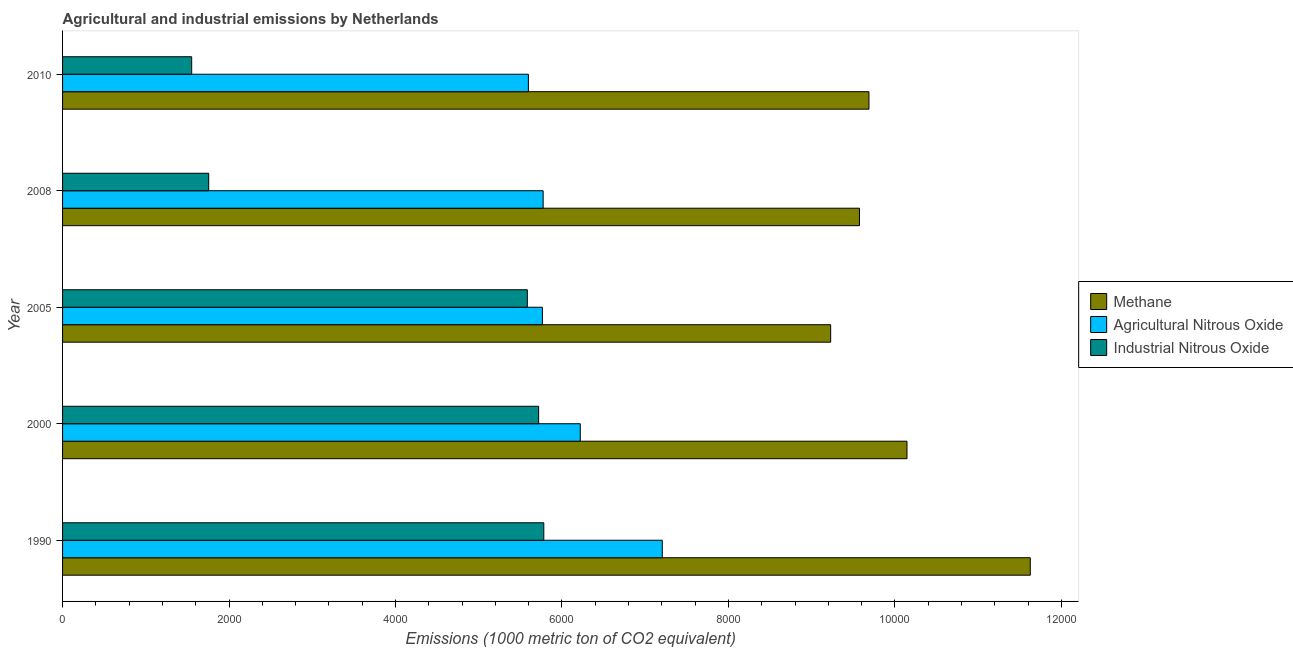Are the number of bars per tick equal to the number of legend labels?
Your response must be concise. Yes. Are the number of bars on each tick of the Y-axis equal?
Your response must be concise. Yes. How many bars are there on the 5th tick from the top?
Provide a short and direct response. 3. What is the label of the 3rd group of bars from the top?
Keep it short and to the point. 2005. What is the amount of agricultural nitrous oxide emissions in 2005?
Ensure brevity in your answer.  5764.8. Across all years, what is the maximum amount of agricultural nitrous oxide emissions?
Offer a terse response. 7205. Across all years, what is the minimum amount of methane emissions?
Your response must be concise. 9228. In which year was the amount of methane emissions maximum?
Your answer should be compact. 1990. In which year was the amount of industrial nitrous oxide emissions minimum?
Your answer should be compact. 2010. What is the total amount of agricultural nitrous oxide emissions in the graph?
Ensure brevity in your answer.  3.06e+04. What is the difference between the amount of industrial nitrous oxide emissions in 2005 and that in 2008?
Your answer should be compact. 3827.9. What is the difference between the amount of industrial nitrous oxide emissions in 2000 and the amount of agricultural nitrous oxide emissions in 2005?
Keep it short and to the point. -45.3. What is the average amount of methane emissions per year?
Keep it short and to the point. 1.01e+04. In the year 2000, what is the difference between the amount of methane emissions and amount of industrial nitrous oxide emissions?
Ensure brevity in your answer.  4425.3. What is the ratio of the amount of industrial nitrous oxide emissions in 2008 to that in 2010?
Ensure brevity in your answer.  1.13. Is the difference between the amount of industrial nitrous oxide emissions in 1990 and 2010 greater than the difference between the amount of methane emissions in 1990 and 2010?
Offer a very short reply. Yes. What is the difference between the highest and the second highest amount of agricultural nitrous oxide emissions?
Give a very brief answer. 985.5. What is the difference between the highest and the lowest amount of agricultural nitrous oxide emissions?
Give a very brief answer. 1608.7. Is the sum of the amount of methane emissions in 2005 and 2008 greater than the maximum amount of agricultural nitrous oxide emissions across all years?
Ensure brevity in your answer.  Yes. What does the 2nd bar from the top in 1990 represents?
Make the answer very short. Agricultural Nitrous Oxide. What does the 1st bar from the bottom in 1990 represents?
Provide a succinct answer. Methane. How many bars are there?
Keep it short and to the point. 15. Are all the bars in the graph horizontal?
Offer a very short reply. Yes. Are the values on the major ticks of X-axis written in scientific E-notation?
Your answer should be very brief. No. Does the graph contain any zero values?
Your answer should be very brief. No. Does the graph contain grids?
Make the answer very short. No. Where does the legend appear in the graph?
Provide a succinct answer. Center right. How many legend labels are there?
Your answer should be compact. 3. What is the title of the graph?
Provide a succinct answer. Agricultural and industrial emissions by Netherlands. Does "Grants" appear as one of the legend labels in the graph?
Your response must be concise. No. What is the label or title of the X-axis?
Ensure brevity in your answer.  Emissions (1000 metric ton of CO2 equivalent). What is the label or title of the Y-axis?
Your response must be concise. Year. What is the Emissions (1000 metric ton of CO2 equivalent) in Methane in 1990?
Offer a very short reply. 1.16e+04. What is the Emissions (1000 metric ton of CO2 equivalent) of Agricultural Nitrous Oxide in 1990?
Offer a terse response. 7205. What is the Emissions (1000 metric ton of CO2 equivalent) in Industrial Nitrous Oxide in 1990?
Make the answer very short. 5781.5. What is the Emissions (1000 metric ton of CO2 equivalent) in Methane in 2000?
Offer a very short reply. 1.01e+04. What is the Emissions (1000 metric ton of CO2 equivalent) of Agricultural Nitrous Oxide in 2000?
Your response must be concise. 6219.5. What is the Emissions (1000 metric ton of CO2 equivalent) of Industrial Nitrous Oxide in 2000?
Ensure brevity in your answer.  5719.5. What is the Emissions (1000 metric ton of CO2 equivalent) of Methane in 2005?
Give a very brief answer. 9228. What is the Emissions (1000 metric ton of CO2 equivalent) of Agricultural Nitrous Oxide in 2005?
Offer a terse response. 5764.8. What is the Emissions (1000 metric ton of CO2 equivalent) in Industrial Nitrous Oxide in 2005?
Your response must be concise. 5583.6. What is the Emissions (1000 metric ton of CO2 equivalent) in Methane in 2008?
Ensure brevity in your answer.  9574.5. What is the Emissions (1000 metric ton of CO2 equivalent) of Agricultural Nitrous Oxide in 2008?
Your answer should be compact. 5773.6. What is the Emissions (1000 metric ton of CO2 equivalent) in Industrial Nitrous Oxide in 2008?
Give a very brief answer. 1755.7. What is the Emissions (1000 metric ton of CO2 equivalent) in Methane in 2010?
Provide a succinct answer. 9687.8. What is the Emissions (1000 metric ton of CO2 equivalent) in Agricultural Nitrous Oxide in 2010?
Your answer should be very brief. 5596.3. What is the Emissions (1000 metric ton of CO2 equivalent) of Industrial Nitrous Oxide in 2010?
Offer a very short reply. 1551.3. Across all years, what is the maximum Emissions (1000 metric ton of CO2 equivalent) of Methane?
Ensure brevity in your answer.  1.16e+04. Across all years, what is the maximum Emissions (1000 metric ton of CO2 equivalent) in Agricultural Nitrous Oxide?
Provide a succinct answer. 7205. Across all years, what is the maximum Emissions (1000 metric ton of CO2 equivalent) of Industrial Nitrous Oxide?
Your answer should be very brief. 5781.5. Across all years, what is the minimum Emissions (1000 metric ton of CO2 equivalent) in Methane?
Your response must be concise. 9228. Across all years, what is the minimum Emissions (1000 metric ton of CO2 equivalent) of Agricultural Nitrous Oxide?
Offer a terse response. 5596.3. Across all years, what is the minimum Emissions (1000 metric ton of CO2 equivalent) in Industrial Nitrous Oxide?
Your answer should be compact. 1551.3. What is the total Emissions (1000 metric ton of CO2 equivalent) in Methane in the graph?
Offer a terse response. 5.03e+04. What is the total Emissions (1000 metric ton of CO2 equivalent) in Agricultural Nitrous Oxide in the graph?
Provide a succinct answer. 3.06e+04. What is the total Emissions (1000 metric ton of CO2 equivalent) in Industrial Nitrous Oxide in the graph?
Your answer should be very brief. 2.04e+04. What is the difference between the Emissions (1000 metric ton of CO2 equivalent) of Methane in 1990 and that in 2000?
Offer a very short reply. 1481.2. What is the difference between the Emissions (1000 metric ton of CO2 equivalent) of Agricultural Nitrous Oxide in 1990 and that in 2000?
Make the answer very short. 985.5. What is the difference between the Emissions (1000 metric ton of CO2 equivalent) of Methane in 1990 and that in 2005?
Your answer should be compact. 2398. What is the difference between the Emissions (1000 metric ton of CO2 equivalent) in Agricultural Nitrous Oxide in 1990 and that in 2005?
Offer a terse response. 1440.2. What is the difference between the Emissions (1000 metric ton of CO2 equivalent) of Industrial Nitrous Oxide in 1990 and that in 2005?
Offer a terse response. 197.9. What is the difference between the Emissions (1000 metric ton of CO2 equivalent) of Methane in 1990 and that in 2008?
Provide a succinct answer. 2051.5. What is the difference between the Emissions (1000 metric ton of CO2 equivalent) of Agricultural Nitrous Oxide in 1990 and that in 2008?
Offer a terse response. 1431.4. What is the difference between the Emissions (1000 metric ton of CO2 equivalent) of Industrial Nitrous Oxide in 1990 and that in 2008?
Give a very brief answer. 4025.8. What is the difference between the Emissions (1000 metric ton of CO2 equivalent) of Methane in 1990 and that in 2010?
Keep it short and to the point. 1938.2. What is the difference between the Emissions (1000 metric ton of CO2 equivalent) in Agricultural Nitrous Oxide in 1990 and that in 2010?
Your answer should be compact. 1608.7. What is the difference between the Emissions (1000 metric ton of CO2 equivalent) in Industrial Nitrous Oxide in 1990 and that in 2010?
Make the answer very short. 4230.2. What is the difference between the Emissions (1000 metric ton of CO2 equivalent) in Methane in 2000 and that in 2005?
Ensure brevity in your answer.  916.8. What is the difference between the Emissions (1000 metric ton of CO2 equivalent) of Agricultural Nitrous Oxide in 2000 and that in 2005?
Your answer should be very brief. 454.7. What is the difference between the Emissions (1000 metric ton of CO2 equivalent) in Industrial Nitrous Oxide in 2000 and that in 2005?
Give a very brief answer. 135.9. What is the difference between the Emissions (1000 metric ton of CO2 equivalent) of Methane in 2000 and that in 2008?
Offer a very short reply. 570.3. What is the difference between the Emissions (1000 metric ton of CO2 equivalent) of Agricultural Nitrous Oxide in 2000 and that in 2008?
Give a very brief answer. 445.9. What is the difference between the Emissions (1000 metric ton of CO2 equivalent) of Industrial Nitrous Oxide in 2000 and that in 2008?
Make the answer very short. 3963.8. What is the difference between the Emissions (1000 metric ton of CO2 equivalent) of Methane in 2000 and that in 2010?
Give a very brief answer. 457. What is the difference between the Emissions (1000 metric ton of CO2 equivalent) in Agricultural Nitrous Oxide in 2000 and that in 2010?
Keep it short and to the point. 623.2. What is the difference between the Emissions (1000 metric ton of CO2 equivalent) of Industrial Nitrous Oxide in 2000 and that in 2010?
Keep it short and to the point. 4168.2. What is the difference between the Emissions (1000 metric ton of CO2 equivalent) of Methane in 2005 and that in 2008?
Offer a very short reply. -346.5. What is the difference between the Emissions (1000 metric ton of CO2 equivalent) of Industrial Nitrous Oxide in 2005 and that in 2008?
Offer a terse response. 3827.9. What is the difference between the Emissions (1000 metric ton of CO2 equivalent) of Methane in 2005 and that in 2010?
Offer a terse response. -459.8. What is the difference between the Emissions (1000 metric ton of CO2 equivalent) in Agricultural Nitrous Oxide in 2005 and that in 2010?
Your answer should be compact. 168.5. What is the difference between the Emissions (1000 metric ton of CO2 equivalent) of Industrial Nitrous Oxide in 2005 and that in 2010?
Your answer should be very brief. 4032.3. What is the difference between the Emissions (1000 metric ton of CO2 equivalent) of Methane in 2008 and that in 2010?
Offer a very short reply. -113.3. What is the difference between the Emissions (1000 metric ton of CO2 equivalent) of Agricultural Nitrous Oxide in 2008 and that in 2010?
Provide a short and direct response. 177.3. What is the difference between the Emissions (1000 metric ton of CO2 equivalent) of Industrial Nitrous Oxide in 2008 and that in 2010?
Offer a very short reply. 204.4. What is the difference between the Emissions (1000 metric ton of CO2 equivalent) in Methane in 1990 and the Emissions (1000 metric ton of CO2 equivalent) in Agricultural Nitrous Oxide in 2000?
Your response must be concise. 5406.5. What is the difference between the Emissions (1000 metric ton of CO2 equivalent) in Methane in 1990 and the Emissions (1000 metric ton of CO2 equivalent) in Industrial Nitrous Oxide in 2000?
Offer a very short reply. 5906.5. What is the difference between the Emissions (1000 metric ton of CO2 equivalent) in Agricultural Nitrous Oxide in 1990 and the Emissions (1000 metric ton of CO2 equivalent) in Industrial Nitrous Oxide in 2000?
Ensure brevity in your answer.  1485.5. What is the difference between the Emissions (1000 metric ton of CO2 equivalent) of Methane in 1990 and the Emissions (1000 metric ton of CO2 equivalent) of Agricultural Nitrous Oxide in 2005?
Your answer should be compact. 5861.2. What is the difference between the Emissions (1000 metric ton of CO2 equivalent) of Methane in 1990 and the Emissions (1000 metric ton of CO2 equivalent) of Industrial Nitrous Oxide in 2005?
Your answer should be compact. 6042.4. What is the difference between the Emissions (1000 metric ton of CO2 equivalent) in Agricultural Nitrous Oxide in 1990 and the Emissions (1000 metric ton of CO2 equivalent) in Industrial Nitrous Oxide in 2005?
Give a very brief answer. 1621.4. What is the difference between the Emissions (1000 metric ton of CO2 equivalent) of Methane in 1990 and the Emissions (1000 metric ton of CO2 equivalent) of Agricultural Nitrous Oxide in 2008?
Offer a terse response. 5852.4. What is the difference between the Emissions (1000 metric ton of CO2 equivalent) in Methane in 1990 and the Emissions (1000 metric ton of CO2 equivalent) in Industrial Nitrous Oxide in 2008?
Your response must be concise. 9870.3. What is the difference between the Emissions (1000 metric ton of CO2 equivalent) in Agricultural Nitrous Oxide in 1990 and the Emissions (1000 metric ton of CO2 equivalent) in Industrial Nitrous Oxide in 2008?
Your answer should be compact. 5449.3. What is the difference between the Emissions (1000 metric ton of CO2 equivalent) in Methane in 1990 and the Emissions (1000 metric ton of CO2 equivalent) in Agricultural Nitrous Oxide in 2010?
Your answer should be compact. 6029.7. What is the difference between the Emissions (1000 metric ton of CO2 equivalent) of Methane in 1990 and the Emissions (1000 metric ton of CO2 equivalent) of Industrial Nitrous Oxide in 2010?
Provide a succinct answer. 1.01e+04. What is the difference between the Emissions (1000 metric ton of CO2 equivalent) in Agricultural Nitrous Oxide in 1990 and the Emissions (1000 metric ton of CO2 equivalent) in Industrial Nitrous Oxide in 2010?
Make the answer very short. 5653.7. What is the difference between the Emissions (1000 metric ton of CO2 equivalent) in Methane in 2000 and the Emissions (1000 metric ton of CO2 equivalent) in Agricultural Nitrous Oxide in 2005?
Ensure brevity in your answer.  4380. What is the difference between the Emissions (1000 metric ton of CO2 equivalent) of Methane in 2000 and the Emissions (1000 metric ton of CO2 equivalent) of Industrial Nitrous Oxide in 2005?
Make the answer very short. 4561.2. What is the difference between the Emissions (1000 metric ton of CO2 equivalent) of Agricultural Nitrous Oxide in 2000 and the Emissions (1000 metric ton of CO2 equivalent) of Industrial Nitrous Oxide in 2005?
Offer a terse response. 635.9. What is the difference between the Emissions (1000 metric ton of CO2 equivalent) in Methane in 2000 and the Emissions (1000 metric ton of CO2 equivalent) in Agricultural Nitrous Oxide in 2008?
Offer a very short reply. 4371.2. What is the difference between the Emissions (1000 metric ton of CO2 equivalent) in Methane in 2000 and the Emissions (1000 metric ton of CO2 equivalent) in Industrial Nitrous Oxide in 2008?
Ensure brevity in your answer.  8389.1. What is the difference between the Emissions (1000 metric ton of CO2 equivalent) of Agricultural Nitrous Oxide in 2000 and the Emissions (1000 metric ton of CO2 equivalent) of Industrial Nitrous Oxide in 2008?
Offer a terse response. 4463.8. What is the difference between the Emissions (1000 metric ton of CO2 equivalent) of Methane in 2000 and the Emissions (1000 metric ton of CO2 equivalent) of Agricultural Nitrous Oxide in 2010?
Keep it short and to the point. 4548.5. What is the difference between the Emissions (1000 metric ton of CO2 equivalent) in Methane in 2000 and the Emissions (1000 metric ton of CO2 equivalent) in Industrial Nitrous Oxide in 2010?
Your answer should be very brief. 8593.5. What is the difference between the Emissions (1000 metric ton of CO2 equivalent) in Agricultural Nitrous Oxide in 2000 and the Emissions (1000 metric ton of CO2 equivalent) in Industrial Nitrous Oxide in 2010?
Give a very brief answer. 4668.2. What is the difference between the Emissions (1000 metric ton of CO2 equivalent) of Methane in 2005 and the Emissions (1000 metric ton of CO2 equivalent) of Agricultural Nitrous Oxide in 2008?
Make the answer very short. 3454.4. What is the difference between the Emissions (1000 metric ton of CO2 equivalent) of Methane in 2005 and the Emissions (1000 metric ton of CO2 equivalent) of Industrial Nitrous Oxide in 2008?
Ensure brevity in your answer.  7472.3. What is the difference between the Emissions (1000 metric ton of CO2 equivalent) of Agricultural Nitrous Oxide in 2005 and the Emissions (1000 metric ton of CO2 equivalent) of Industrial Nitrous Oxide in 2008?
Your response must be concise. 4009.1. What is the difference between the Emissions (1000 metric ton of CO2 equivalent) in Methane in 2005 and the Emissions (1000 metric ton of CO2 equivalent) in Agricultural Nitrous Oxide in 2010?
Make the answer very short. 3631.7. What is the difference between the Emissions (1000 metric ton of CO2 equivalent) of Methane in 2005 and the Emissions (1000 metric ton of CO2 equivalent) of Industrial Nitrous Oxide in 2010?
Your answer should be very brief. 7676.7. What is the difference between the Emissions (1000 metric ton of CO2 equivalent) of Agricultural Nitrous Oxide in 2005 and the Emissions (1000 metric ton of CO2 equivalent) of Industrial Nitrous Oxide in 2010?
Make the answer very short. 4213.5. What is the difference between the Emissions (1000 metric ton of CO2 equivalent) of Methane in 2008 and the Emissions (1000 metric ton of CO2 equivalent) of Agricultural Nitrous Oxide in 2010?
Your response must be concise. 3978.2. What is the difference between the Emissions (1000 metric ton of CO2 equivalent) of Methane in 2008 and the Emissions (1000 metric ton of CO2 equivalent) of Industrial Nitrous Oxide in 2010?
Provide a succinct answer. 8023.2. What is the difference between the Emissions (1000 metric ton of CO2 equivalent) of Agricultural Nitrous Oxide in 2008 and the Emissions (1000 metric ton of CO2 equivalent) of Industrial Nitrous Oxide in 2010?
Provide a short and direct response. 4222.3. What is the average Emissions (1000 metric ton of CO2 equivalent) in Methane per year?
Offer a very short reply. 1.01e+04. What is the average Emissions (1000 metric ton of CO2 equivalent) in Agricultural Nitrous Oxide per year?
Make the answer very short. 6111.84. What is the average Emissions (1000 metric ton of CO2 equivalent) of Industrial Nitrous Oxide per year?
Offer a very short reply. 4078.32. In the year 1990, what is the difference between the Emissions (1000 metric ton of CO2 equivalent) of Methane and Emissions (1000 metric ton of CO2 equivalent) of Agricultural Nitrous Oxide?
Your response must be concise. 4421. In the year 1990, what is the difference between the Emissions (1000 metric ton of CO2 equivalent) in Methane and Emissions (1000 metric ton of CO2 equivalent) in Industrial Nitrous Oxide?
Provide a short and direct response. 5844.5. In the year 1990, what is the difference between the Emissions (1000 metric ton of CO2 equivalent) in Agricultural Nitrous Oxide and Emissions (1000 metric ton of CO2 equivalent) in Industrial Nitrous Oxide?
Your response must be concise. 1423.5. In the year 2000, what is the difference between the Emissions (1000 metric ton of CO2 equivalent) in Methane and Emissions (1000 metric ton of CO2 equivalent) in Agricultural Nitrous Oxide?
Offer a very short reply. 3925.3. In the year 2000, what is the difference between the Emissions (1000 metric ton of CO2 equivalent) in Methane and Emissions (1000 metric ton of CO2 equivalent) in Industrial Nitrous Oxide?
Offer a very short reply. 4425.3. In the year 2005, what is the difference between the Emissions (1000 metric ton of CO2 equivalent) of Methane and Emissions (1000 metric ton of CO2 equivalent) of Agricultural Nitrous Oxide?
Your answer should be very brief. 3463.2. In the year 2005, what is the difference between the Emissions (1000 metric ton of CO2 equivalent) in Methane and Emissions (1000 metric ton of CO2 equivalent) in Industrial Nitrous Oxide?
Offer a terse response. 3644.4. In the year 2005, what is the difference between the Emissions (1000 metric ton of CO2 equivalent) in Agricultural Nitrous Oxide and Emissions (1000 metric ton of CO2 equivalent) in Industrial Nitrous Oxide?
Make the answer very short. 181.2. In the year 2008, what is the difference between the Emissions (1000 metric ton of CO2 equivalent) of Methane and Emissions (1000 metric ton of CO2 equivalent) of Agricultural Nitrous Oxide?
Your response must be concise. 3800.9. In the year 2008, what is the difference between the Emissions (1000 metric ton of CO2 equivalent) of Methane and Emissions (1000 metric ton of CO2 equivalent) of Industrial Nitrous Oxide?
Ensure brevity in your answer.  7818.8. In the year 2008, what is the difference between the Emissions (1000 metric ton of CO2 equivalent) in Agricultural Nitrous Oxide and Emissions (1000 metric ton of CO2 equivalent) in Industrial Nitrous Oxide?
Offer a terse response. 4017.9. In the year 2010, what is the difference between the Emissions (1000 metric ton of CO2 equivalent) in Methane and Emissions (1000 metric ton of CO2 equivalent) in Agricultural Nitrous Oxide?
Keep it short and to the point. 4091.5. In the year 2010, what is the difference between the Emissions (1000 metric ton of CO2 equivalent) of Methane and Emissions (1000 metric ton of CO2 equivalent) of Industrial Nitrous Oxide?
Give a very brief answer. 8136.5. In the year 2010, what is the difference between the Emissions (1000 metric ton of CO2 equivalent) of Agricultural Nitrous Oxide and Emissions (1000 metric ton of CO2 equivalent) of Industrial Nitrous Oxide?
Your answer should be very brief. 4045. What is the ratio of the Emissions (1000 metric ton of CO2 equivalent) in Methane in 1990 to that in 2000?
Give a very brief answer. 1.15. What is the ratio of the Emissions (1000 metric ton of CO2 equivalent) in Agricultural Nitrous Oxide in 1990 to that in 2000?
Your response must be concise. 1.16. What is the ratio of the Emissions (1000 metric ton of CO2 equivalent) of Industrial Nitrous Oxide in 1990 to that in 2000?
Your answer should be very brief. 1.01. What is the ratio of the Emissions (1000 metric ton of CO2 equivalent) of Methane in 1990 to that in 2005?
Offer a very short reply. 1.26. What is the ratio of the Emissions (1000 metric ton of CO2 equivalent) of Agricultural Nitrous Oxide in 1990 to that in 2005?
Your answer should be very brief. 1.25. What is the ratio of the Emissions (1000 metric ton of CO2 equivalent) of Industrial Nitrous Oxide in 1990 to that in 2005?
Offer a terse response. 1.04. What is the ratio of the Emissions (1000 metric ton of CO2 equivalent) of Methane in 1990 to that in 2008?
Give a very brief answer. 1.21. What is the ratio of the Emissions (1000 metric ton of CO2 equivalent) in Agricultural Nitrous Oxide in 1990 to that in 2008?
Ensure brevity in your answer.  1.25. What is the ratio of the Emissions (1000 metric ton of CO2 equivalent) of Industrial Nitrous Oxide in 1990 to that in 2008?
Your answer should be compact. 3.29. What is the ratio of the Emissions (1000 metric ton of CO2 equivalent) of Methane in 1990 to that in 2010?
Make the answer very short. 1.2. What is the ratio of the Emissions (1000 metric ton of CO2 equivalent) of Agricultural Nitrous Oxide in 1990 to that in 2010?
Keep it short and to the point. 1.29. What is the ratio of the Emissions (1000 metric ton of CO2 equivalent) in Industrial Nitrous Oxide in 1990 to that in 2010?
Offer a very short reply. 3.73. What is the ratio of the Emissions (1000 metric ton of CO2 equivalent) of Methane in 2000 to that in 2005?
Your response must be concise. 1.1. What is the ratio of the Emissions (1000 metric ton of CO2 equivalent) of Agricultural Nitrous Oxide in 2000 to that in 2005?
Offer a terse response. 1.08. What is the ratio of the Emissions (1000 metric ton of CO2 equivalent) in Industrial Nitrous Oxide in 2000 to that in 2005?
Your answer should be compact. 1.02. What is the ratio of the Emissions (1000 metric ton of CO2 equivalent) of Methane in 2000 to that in 2008?
Your response must be concise. 1.06. What is the ratio of the Emissions (1000 metric ton of CO2 equivalent) in Agricultural Nitrous Oxide in 2000 to that in 2008?
Provide a short and direct response. 1.08. What is the ratio of the Emissions (1000 metric ton of CO2 equivalent) of Industrial Nitrous Oxide in 2000 to that in 2008?
Keep it short and to the point. 3.26. What is the ratio of the Emissions (1000 metric ton of CO2 equivalent) of Methane in 2000 to that in 2010?
Your answer should be very brief. 1.05. What is the ratio of the Emissions (1000 metric ton of CO2 equivalent) in Agricultural Nitrous Oxide in 2000 to that in 2010?
Ensure brevity in your answer.  1.11. What is the ratio of the Emissions (1000 metric ton of CO2 equivalent) of Industrial Nitrous Oxide in 2000 to that in 2010?
Provide a short and direct response. 3.69. What is the ratio of the Emissions (1000 metric ton of CO2 equivalent) in Methane in 2005 to that in 2008?
Your answer should be compact. 0.96. What is the ratio of the Emissions (1000 metric ton of CO2 equivalent) of Agricultural Nitrous Oxide in 2005 to that in 2008?
Keep it short and to the point. 1. What is the ratio of the Emissions (1000 metric ton of CO2 equivalent) in Industrial Nitrous Oxide in 2005 to that in 2008?
Provide a succinct answer. 3.18. What is the ratio of the Emissions (1000 metric ton of CO2 equivalent) of Methane in 2005 to that in 2010?
Ensure brevity in your answer.  0.95. What is the ratio of the Emissions (1000 metric ton of CO2 equivalent) of Agricultural Nitrous Oxide in 2005 to that in 2010?
Your response must be concise. 1.03. What is the ratio of the Emissions (1000 metric ton of CO2 equivalent) in Industrial Nitrous Oxide in 2005 to that in 2010?
Offer a terse response. 3.6. What is the ratio of the Emissions (1000 metric ton of CO2 equivalent) in Methane in 2008 to that in 2010?
Your response must be concise. 0.99. What is the ratio of the Emissions (1000 metric ton of CO2 equivalent) of Agricultural Nitrous Oxide in 2008 to that in 2010?
Your response must be concise. 1.03. What is the ratio of the Emissions (1000 metric ton of CO2 equivalent) of Industrial Nitrous Oxide in 2008 to that in 2010?
Your response must be concise. 1.13. What is the difference between the highest and the second highest Emissions (1000 metric ton of CO2 equivalent) in Methane?
Offer a very short reply. 1481.2. What is the difference between the highest and the second highest Emissions (1000 metric ton of CO2 equivalent) in Agricultural Nitrous Oxide?
Provide a succinct answer. 985.5. What is the difference between the highest and the lowest Emissions (1000 metric ton of CO2 equivalent) of Methane?
Make the answer very short. 2398. What is the difference between the highest and the lowest Emissions (1000 metric ton of CO2 equivalent) in Agricultural Nitrous Oxide?
Your answer should be compact. 1608.7. What is the difference between the highest and the lowest Emissions (1000 metric ton of CO2 equivalent) of Industrial Nitrous Oxide?
Your answer should be very brief. 4230.2. 